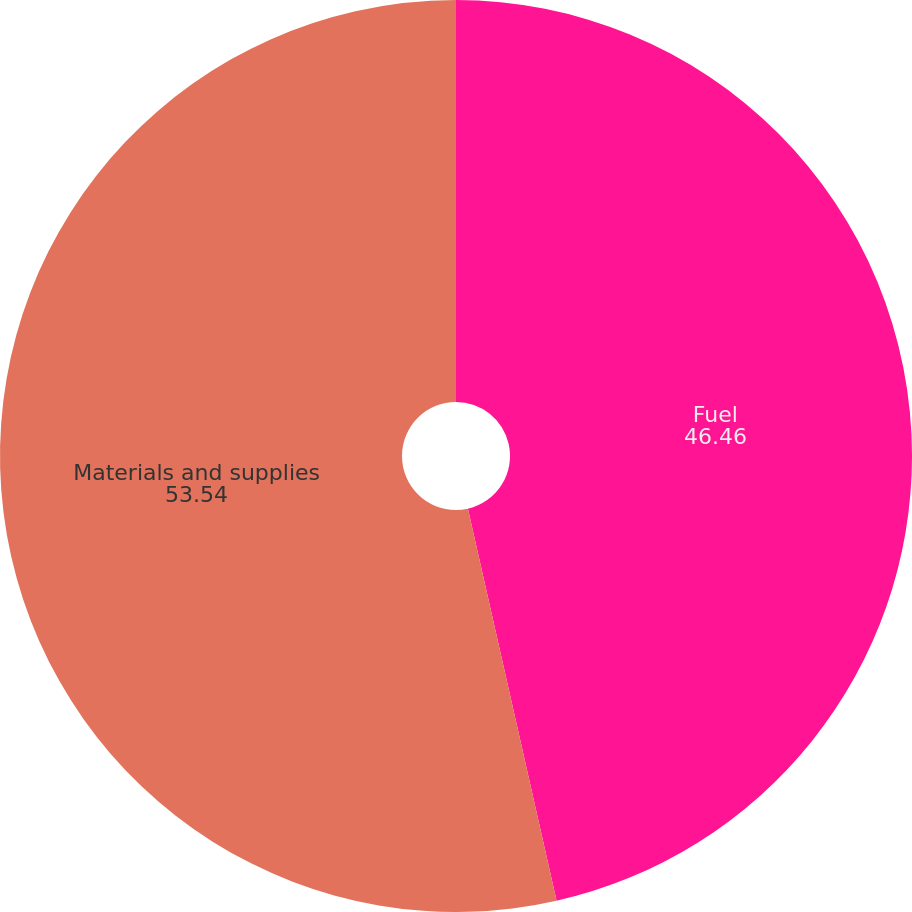Convert chart. <chart><loc_0><loc_0><loc_500><loc_500><pie_chart><fcel>Fuel<fcel>Materials and supplies<nl><fcel>46.46%<fcel>53.54%<nl></chart> 